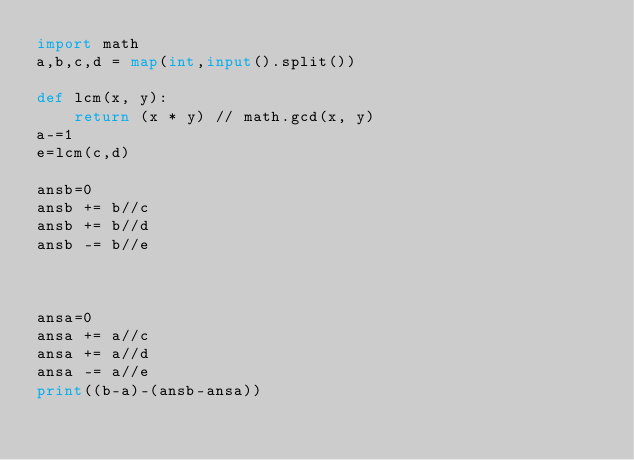Convert code to text. <code><loc_0><loc_0><loc_500><loc_500><_Python_>import math
a,b,c,d = map(int,input().split()) 

def lcm(x, y):
    return (x * y) // math.gcd(x, y)
a-=1
e=lcm(c,d)

ansb=0
ansb += b//c
ansb += b//d
ansb -= b//e



ansa=0
ansa += a//c
ansa += a//d
ansa -= a//e
print((b-a)-(ansb-ansa))</code> 